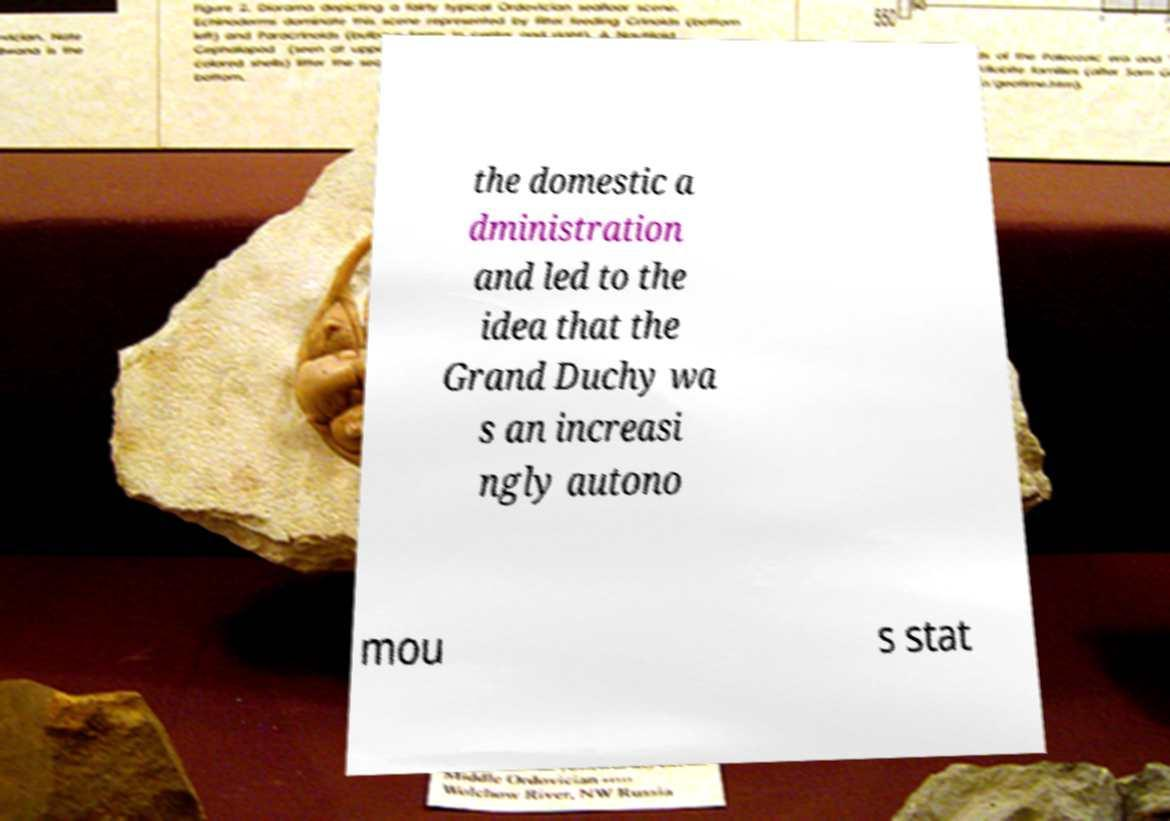Can you accurately transcribe the text from the provided image for me? the domestic a dministration and led to the idea that the Grand Duchy wa s an increasi ngly autono mou s stat 